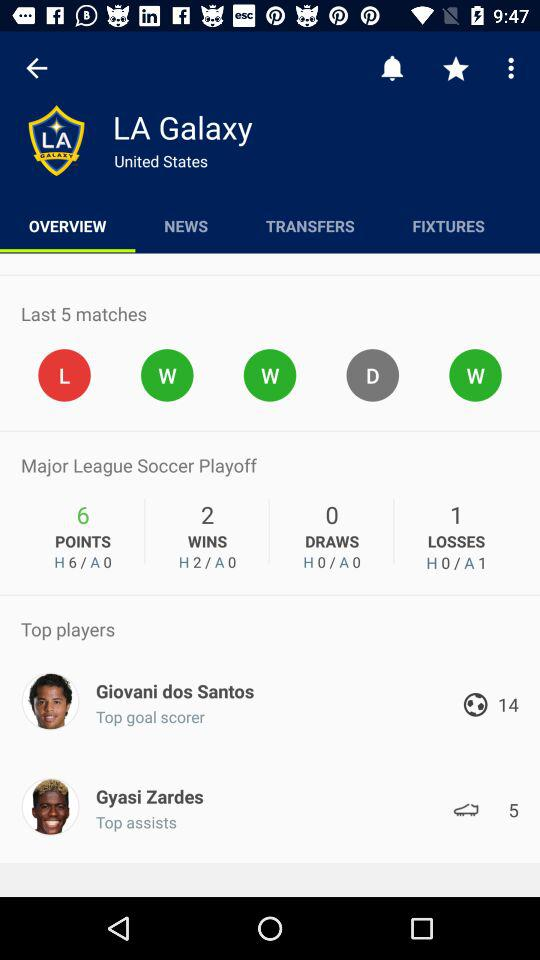How many goals has Giovani dos Santos scored? 14 